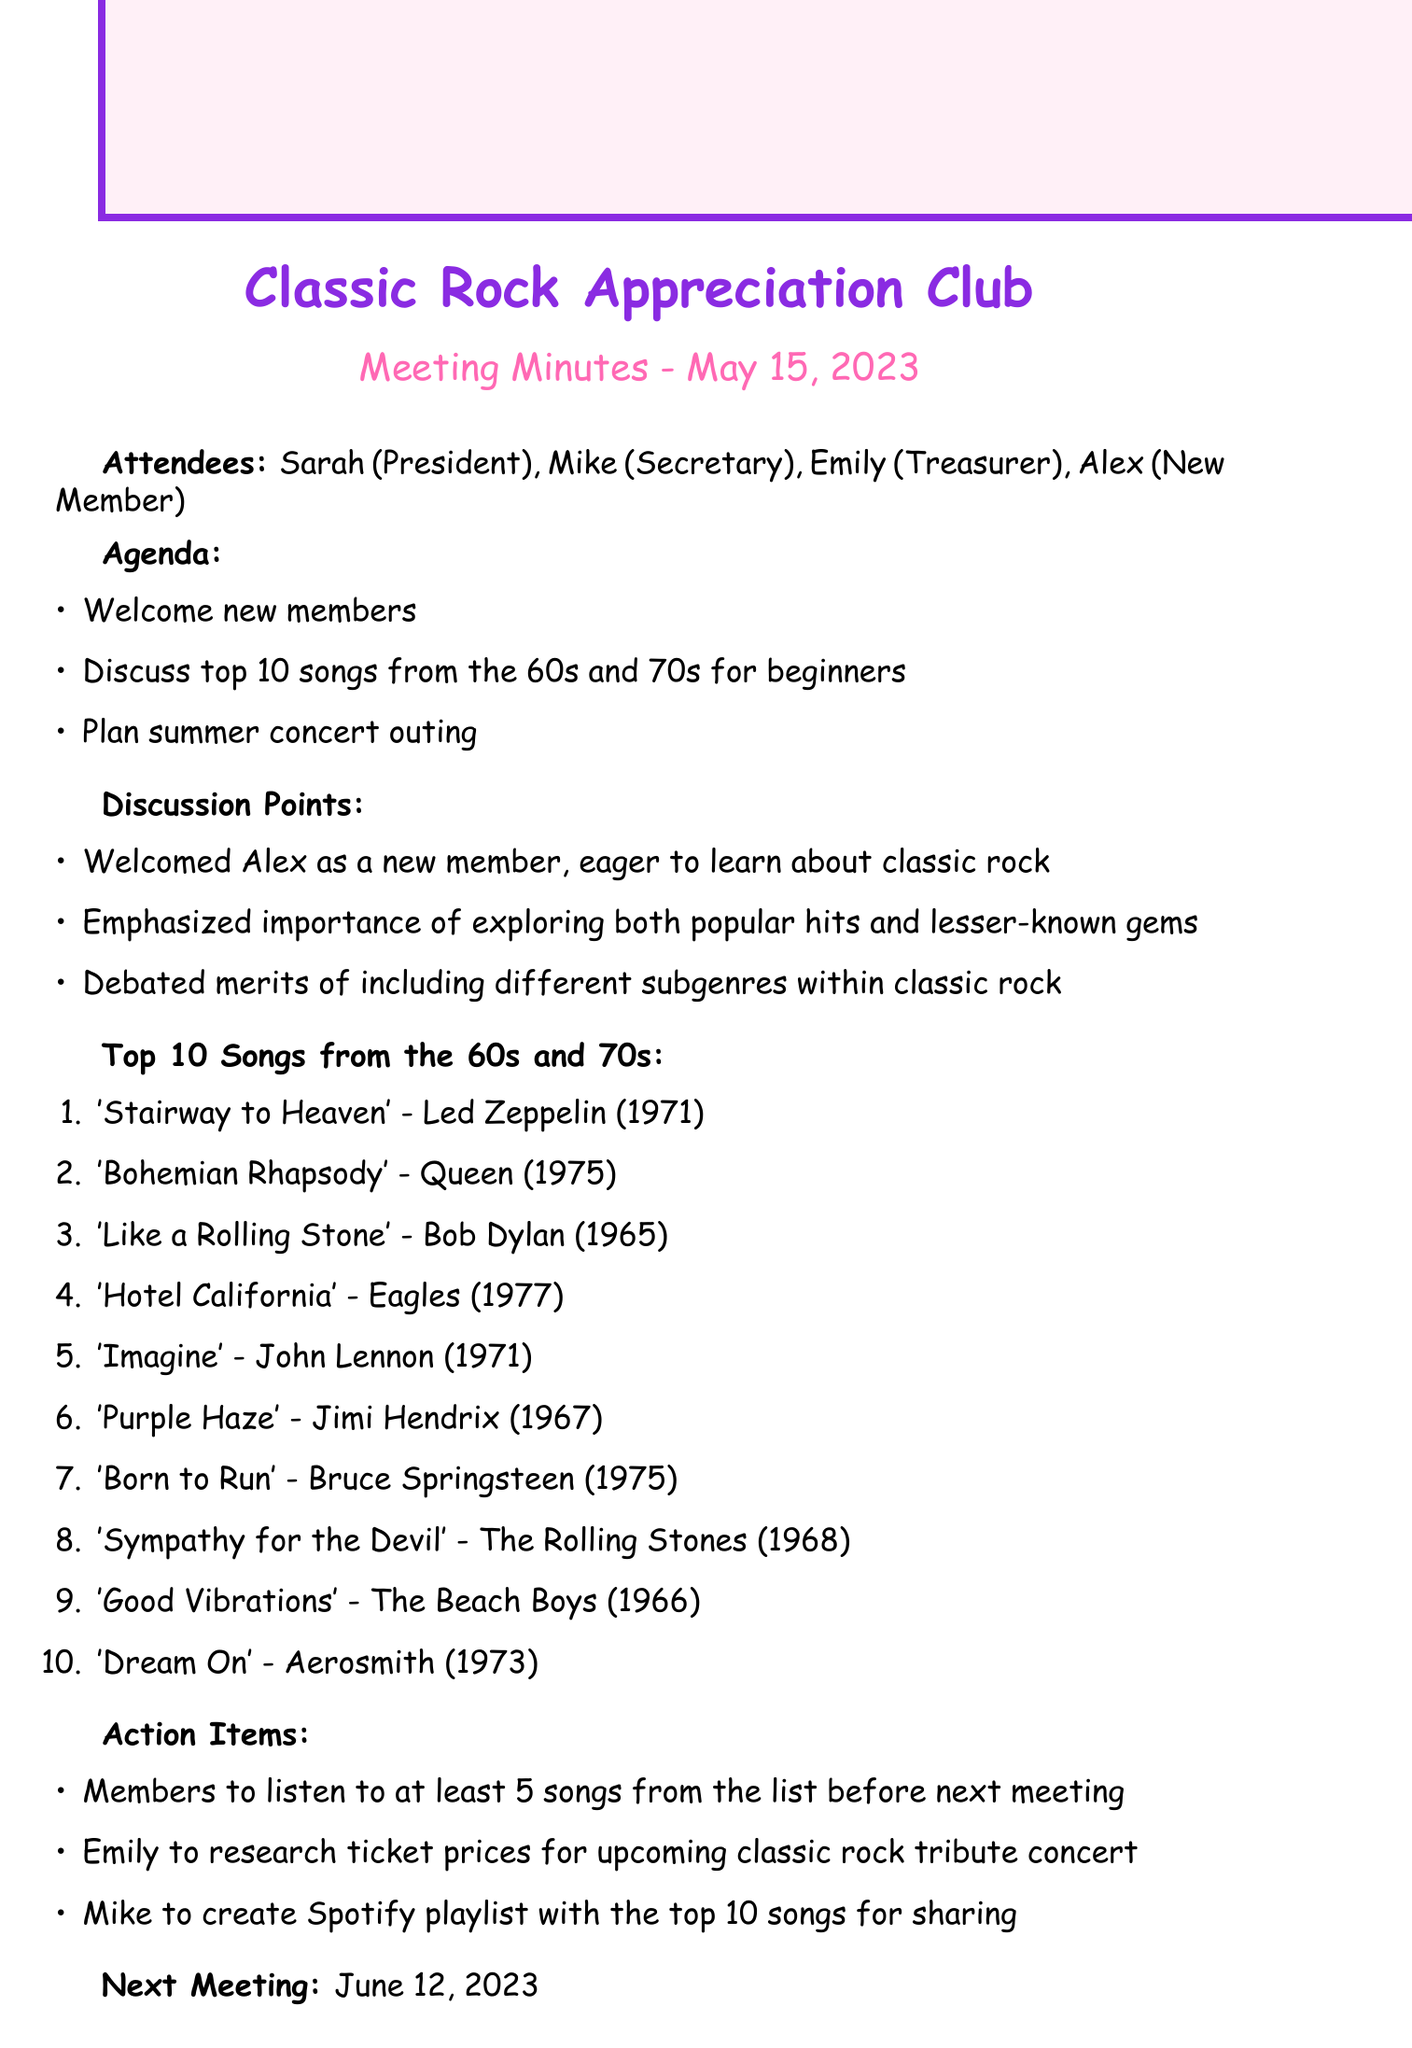What is the meeting date? The meeting date is explicitly stated in the document as May 15, 2023.
Answer: May 15, 2023 Who is the treasurer? The treasurer is mentioned in the list of attendees, specifically as Emily.
Answer: Emily What are the top three songs listed? The document provides a list of the top ten songs, from which the first three are required for this question.
Answer: 'Stairway to Heaven' - Led Zeppelin, 'Bohemian Rhapsody' - Queen, 'Like a Rolling Stone' - Bob Dylan What is the next meeting date? The next meeting date is indicated at the end of the document.
Answer: June 12, 2023 How many members are in attendance? The document lists four attendees at the meeting, which includes a new member.
Answer: Four What is the action item concerning the Spotify playlist? The document specifies what Mike will do regarding the Spotify playlist.
Answer: To create Spotify playlist with the top 10 songs for sharing Why was Alex welcomed at the meeting? The document states that Alex was welcomed as a new member eager to learn about classic rock.
Answer: Eager to learn about classic rock What is emphasized about song exploration? The discussion point highlights an emphasis mentioned during the meeting about song exploration.
Answer: Importance of exploring both popular hits and lesser-known gems 